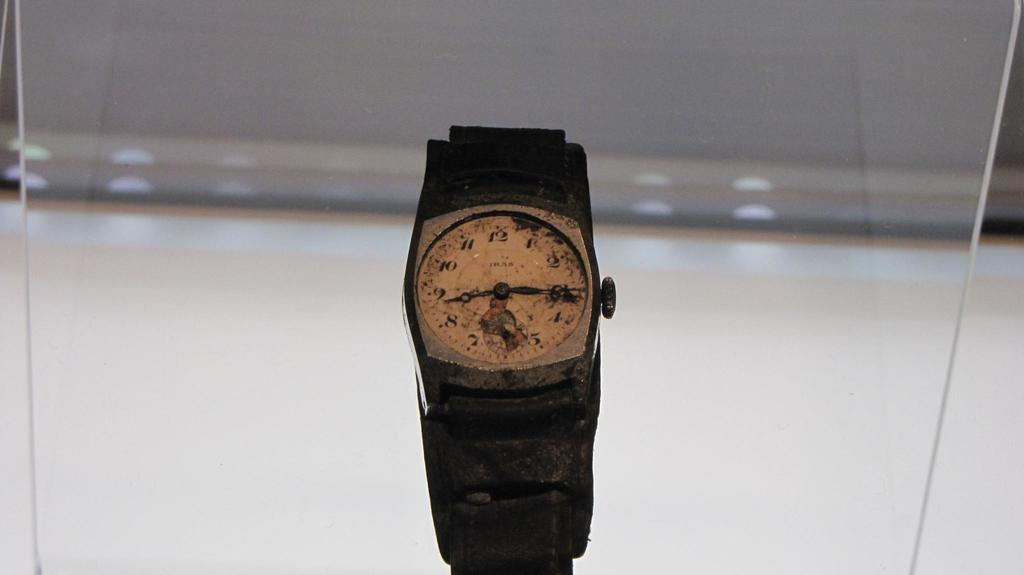<image>
Share a concise interpretation of the image provided. A very old watch  behind plastic that is set to about 8:15 